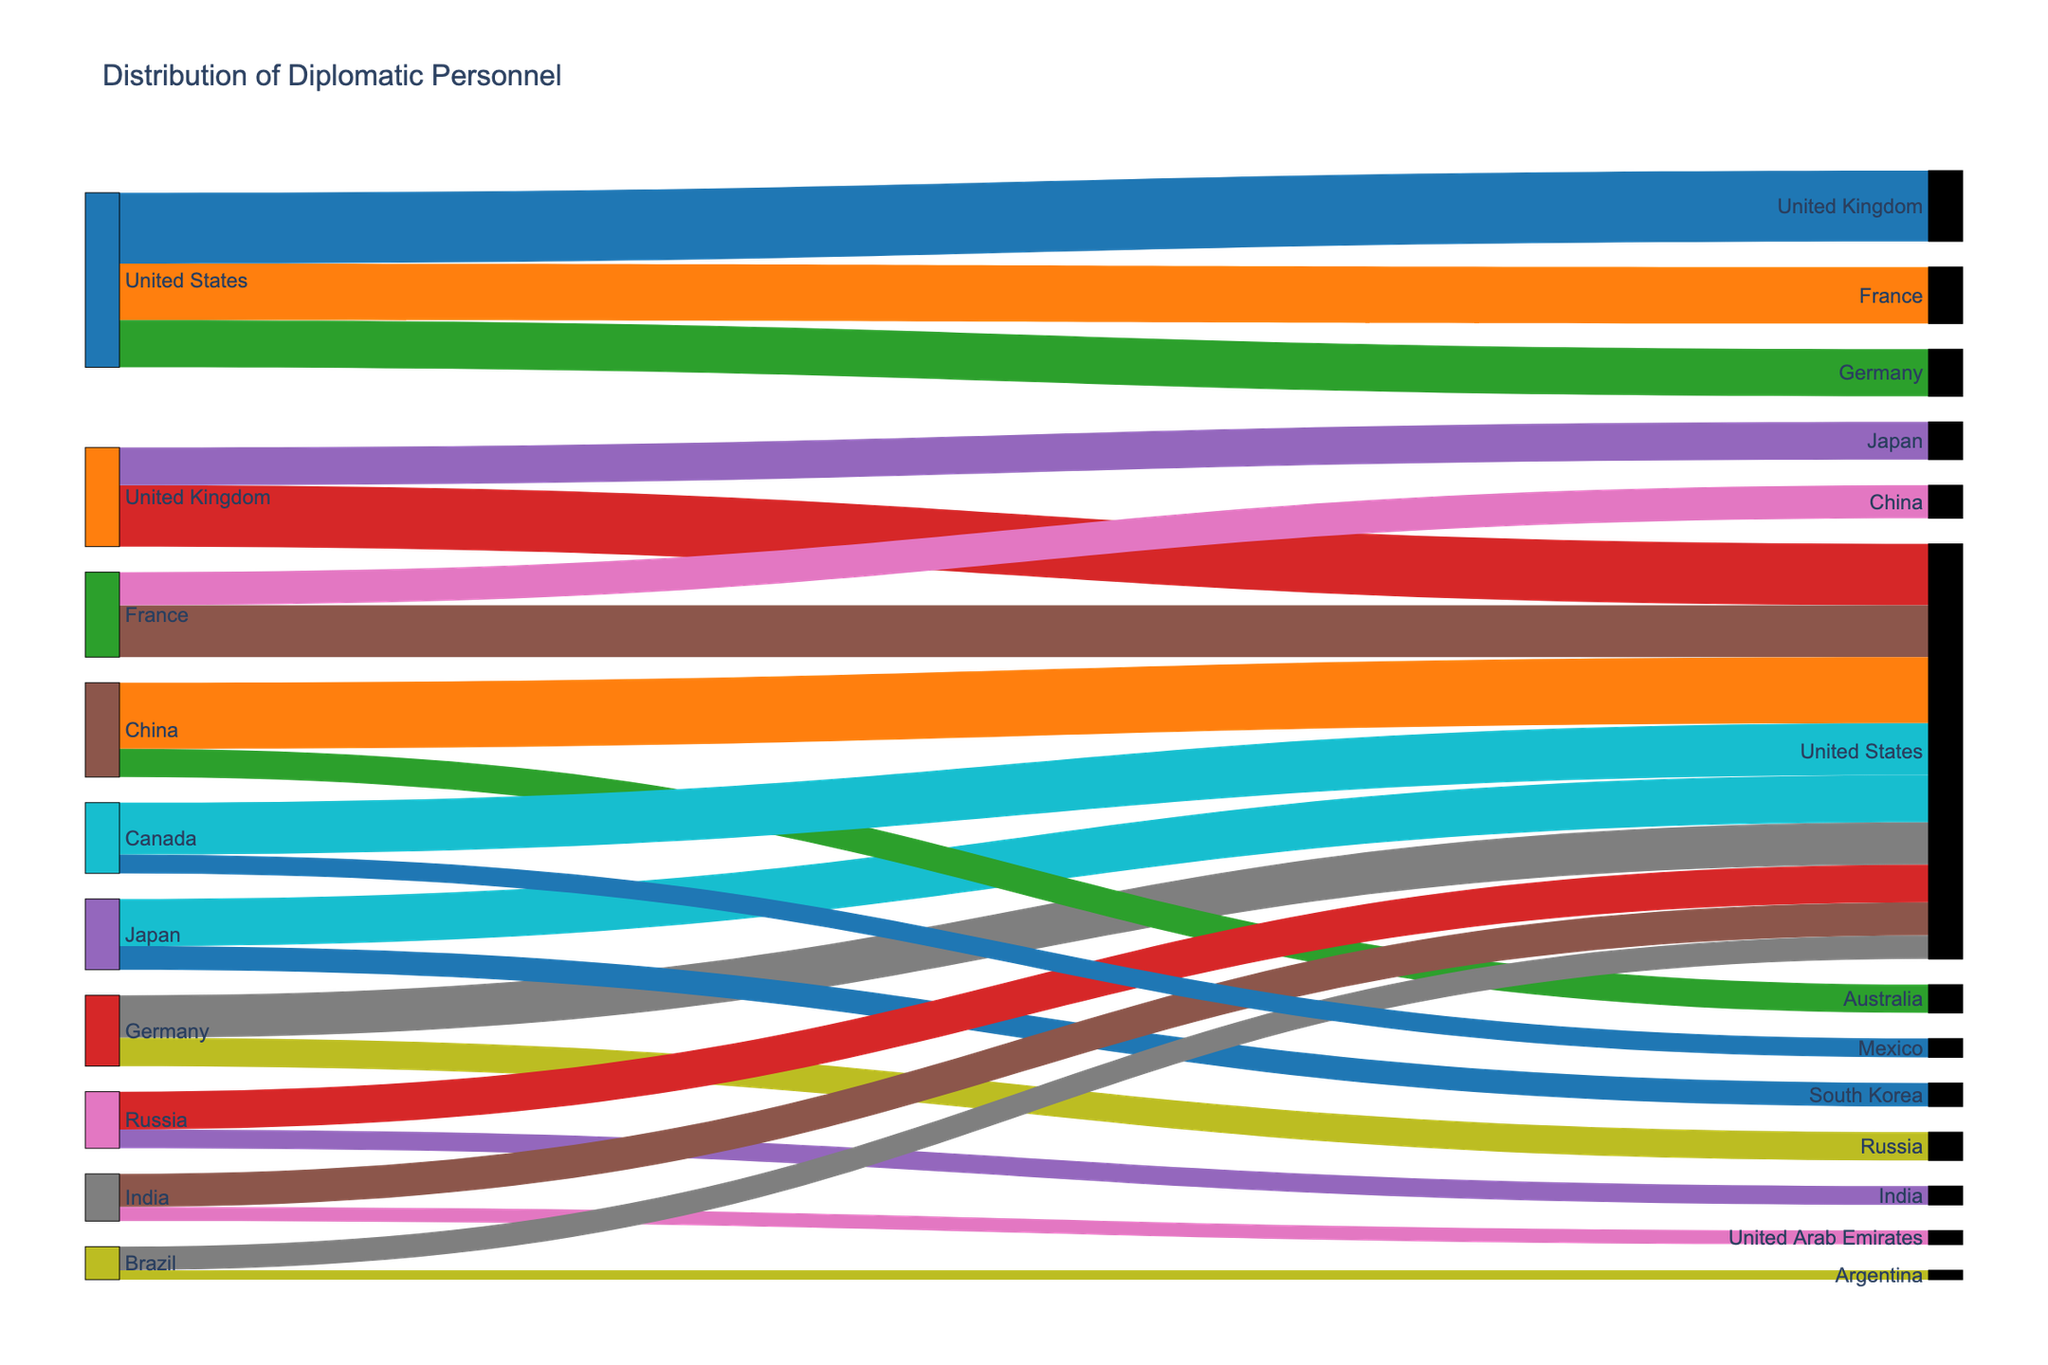Which country has the highest number of diplomatic personnel based abroad? By looking at the width of the flows from each country of origin, the United States has wider flows going to various other countries compared to others.
Answer: United States How many diplomatic personnel from France are hosted by China? By following the flow from France to China in the diagram and looking at the value label on the flow, it shows the number 70.
Answer: 70 What is the total number of diplomatic personnel from China abroad? Sum the values of the outgoing flows from China: United States (140) + Australia (60) = 200.
Answer: 200 Which country receives the highest number of diplomatic personnel overall? By looking at the flows into each host country, the United States receives the most flows from various countries, with each flow having significant values.
Answer: United States How many diplomatic personnel are hosted by the United Kingdom? Sum the values of the incoming flows to the United Kingdom: United States (150).
Answer: 150 Out of Germany and Russia, which country sends more diplomatic personnel to the United States? Compare the values from Germany to United States (90) and Russia to United States (80). Germany has a higher value.
Answer: Germany What is the total number of diplomatic personnel exchanged between the United States and Canada? Add the flow from the United States to Canada (0) and from Canada to the United States (110).
Answer: 110 Which country sends more diplomats to South Korea, and how many? Follow the flows to South Korea, only Japan sends diplomats to South Korea with a value of 50.
Answer: Japan, 50 Among the countries listed, which has the smallest number of outgoing diplomatic personnel to a single country and what is the value? Look for the smallest value in the outgoing flows. Brazil sends the least to Argentina with a value of 20.
Answer: Brazil, 20 